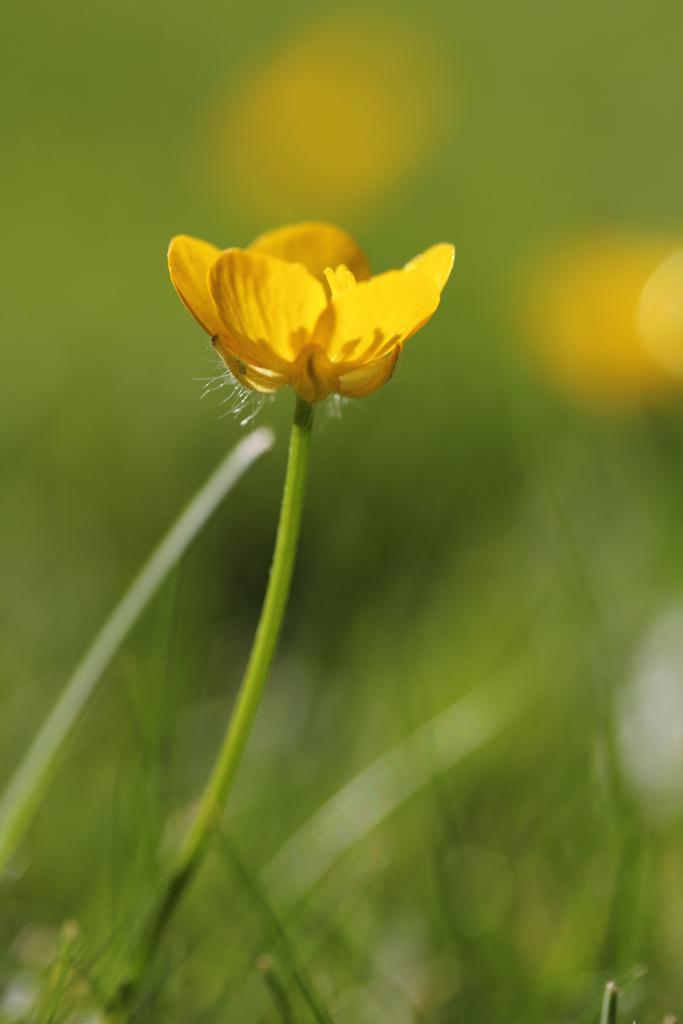What is present in the image? There are flowers in the image. Can you describe the background of the image? The background of the image is blurry. Are there any cherries hanging from the flowers in the image? There is no mention of cherries in the image; it only features flowers. Can you see any fairies flying around the flowers in the image? There is no mention of fairies in the image; it only features flowers and a blurry background. 